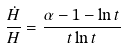<formula> <loc_0><loc_0><loc_500><loc_500>\frac { \dot { H } } { H } = \frac { \alpha - 1 - \ln t } { t \ln t }</formula> 